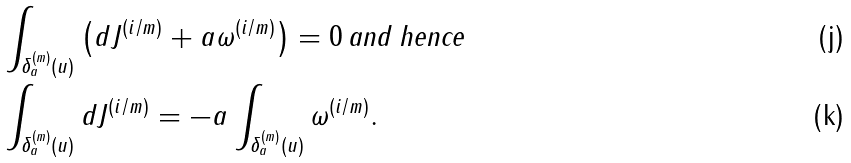<formula> <loc_0><loc_0><loc_500><loc_500>& \int _ { \delta _ { a } ^ { ( m ) } ( u ) } \left ( d J ^ { ( { i } / { m } ) } + a \omega ^ { ( { i } / { m } ) } \right ) = 0 \, \text {and hence} \\ & \int _ { \delta _ { a } ^ { ( m ) } ( u ) } d J ^ { ( { i } / { m } ) } = - a \int _ { \delta _ { a } ^ { ( m ) } ( u ) } \omega ^ { ( { i } / { m } ) } .</formula> 